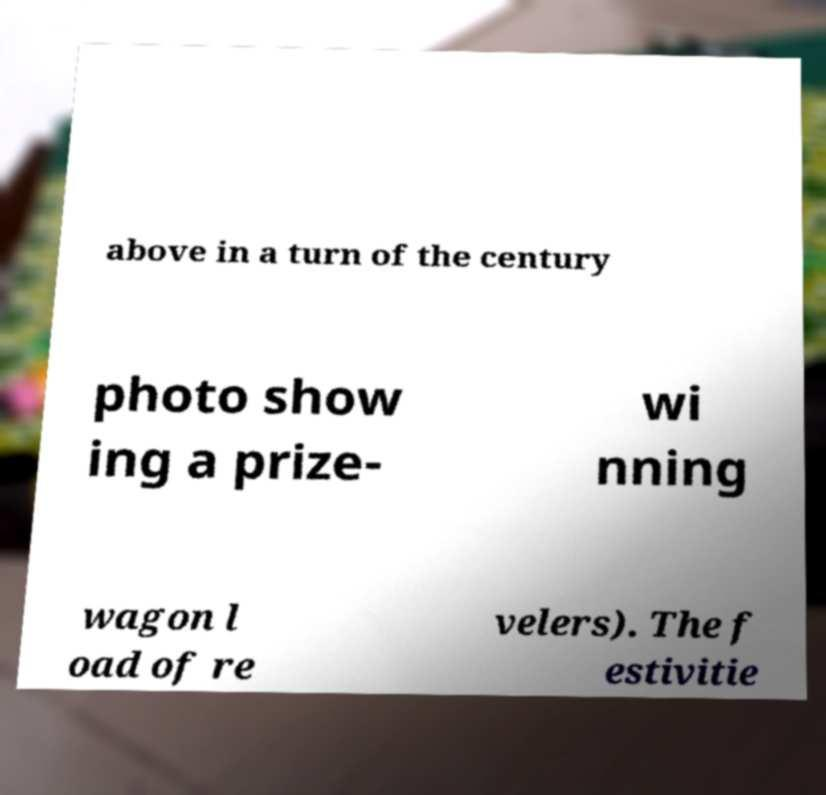I need the written content from this picture converted into text. Can you do that? above in a turn of the century photo show ing a prize- wi nning wagon l oad of re velers). The f estivitie 